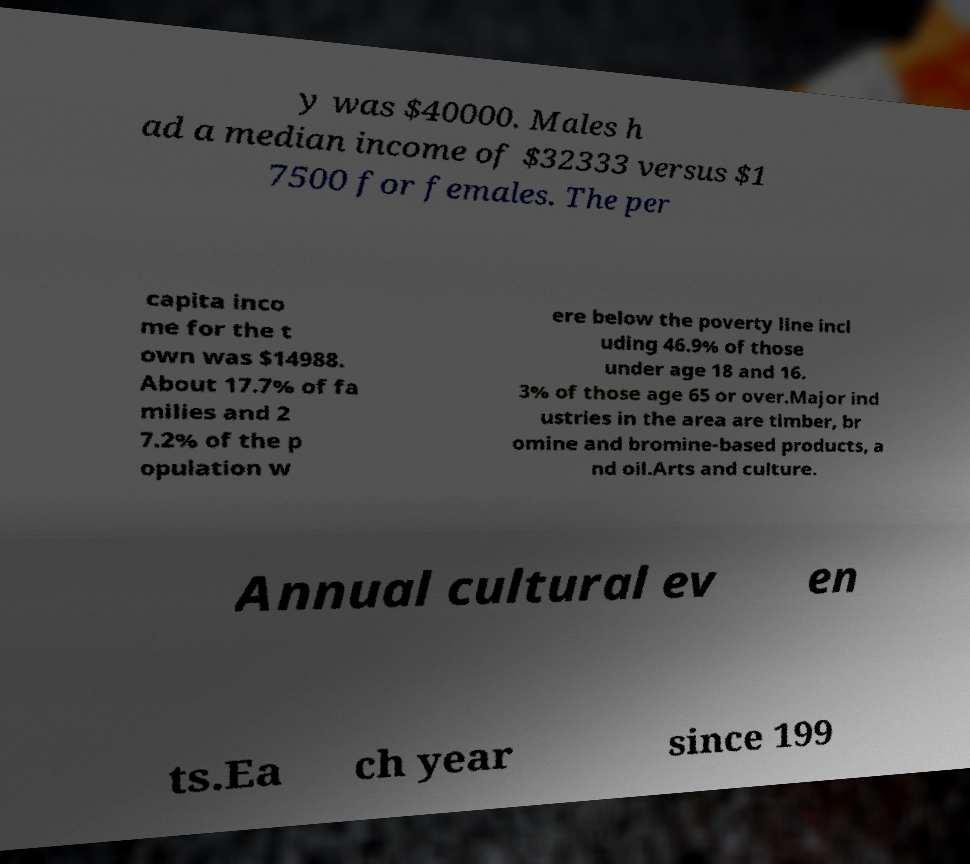For documentation purposes, I need the text within this image transcribed. Could you provide that? y was $40000. Males h ad a median income of $32333 versus $1 7500 for females. The per capita inco me for the t own was $14988. About 17.7% of fa milies and 2 7.2% of the p opulation w ere below the poverty line incl uding 46.9% of those under age 18 and 16. 3% of those age 65 or over.Major ind ustries in the area are timber, br omine and bromine-based products, a nd oil.Arts and culture. Annual cultural ev en ts.Ea ch year since 199 